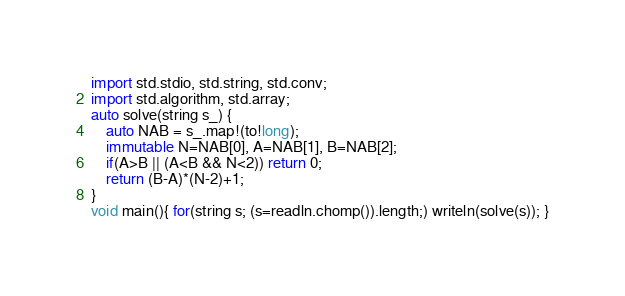Convert code to text. <code><loc_0><loc_0><loc_500><loc_500><_D_>import std.stdio, std.string, std.conv;
import std.algorithm, std.array;
auto solve(string s_) {
    auto NAB = s_.map!(to!long);
    immutable N=NAB[0], A=NAB[1], B=NAB[2];
    if(A>B || (A<B && N<2)) return 0;
    return (B-A)*(N-2)+1;
}
void main(){ for(string s; (s=readln.chomp()).length;) writeln(solve(s)); }</code> 